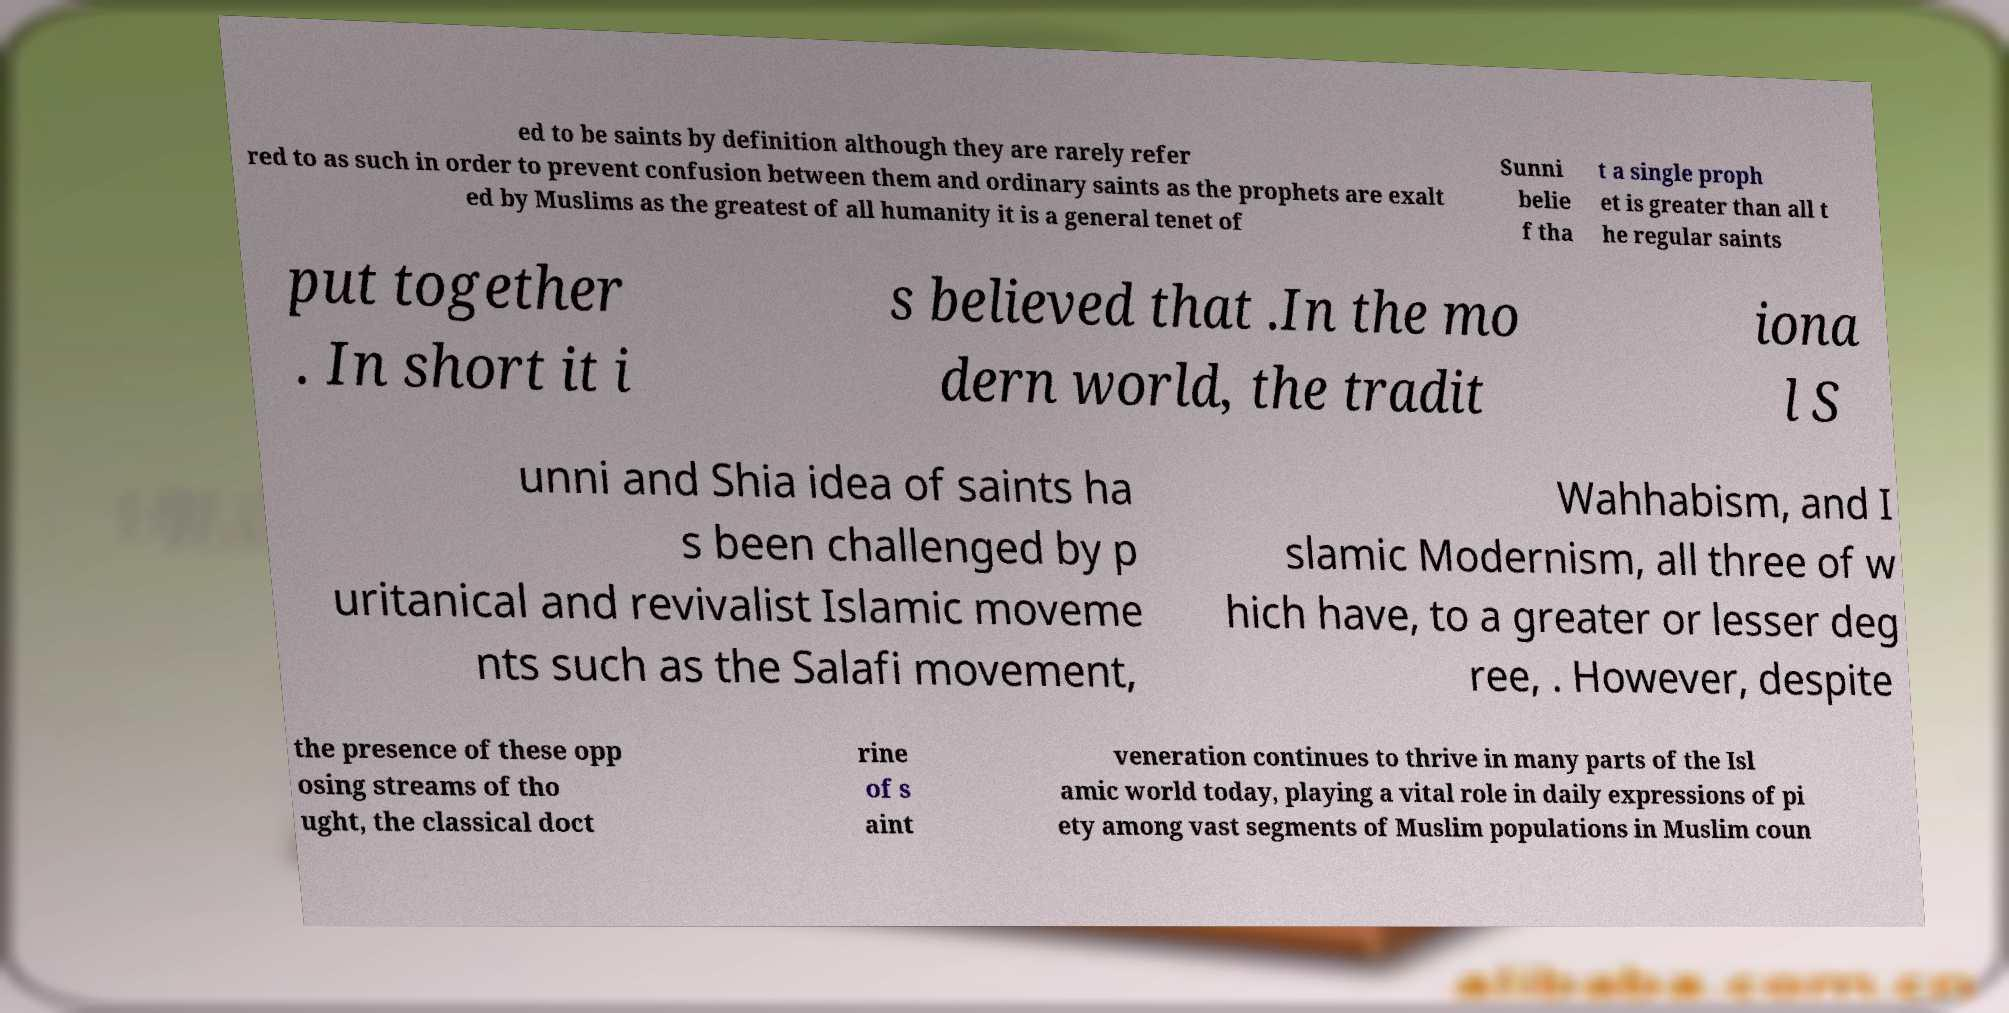Can you read and provide the text displayed in the image?This photo seems to have some interesting text. Can you extract and type it out for me? ed to be saints by definition although they are rarely refer red to as such in order to prevent confusion between them and ordinary saints as the prophets are exalt ed by Muslims as the greatest of all humanity it is a general tenet of Sunni belie f tha t a single proph et is greater than all t he regular saints put together . In short it i s believed that .In the mo dern world, the tradit iona l S unni and Shia idea of saints ha s been challenged by p uritanical and revivalist Islamic moveme nts such as the Salafi movement, Wahhabism, and I slamic Modernism, all three of w hich have, to a greater or lesser deg ree, . However, despite the presence of these opp osing streams of tho ught, the classical doct rine of s aint veneration continues to thrive in many parts of the Isl amic world today, playing a vital role in daily expressions of pi ety among vast segments of Muslim populations in Muslim coun 